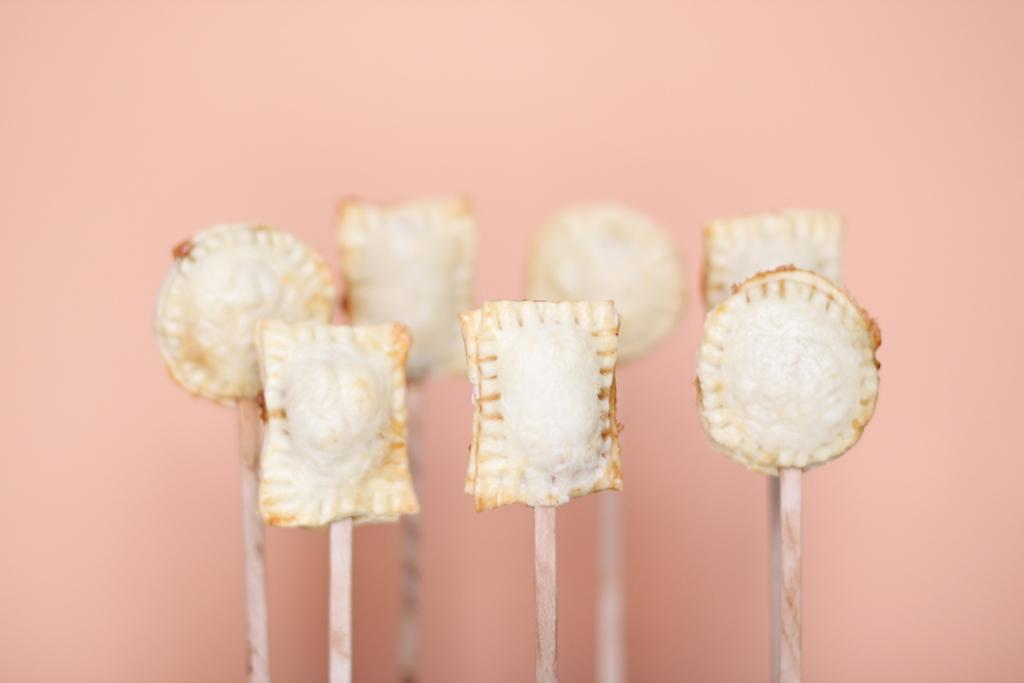What is the main subject in the center of the image? There is a white color object in the center of the image, which seems to be food items. What can be seen accompanying the main subject? There are wooden sticks visible in the image. What color and location is the secondary object in the image? There is a pink color object in the background of the image. Is there a crown visible on the food items in the image? No, there is no crown present on the food items in the image. Can you see a swing in the background of the image? No, there is no swing visible in the image; only the pink color object is present in the background. 